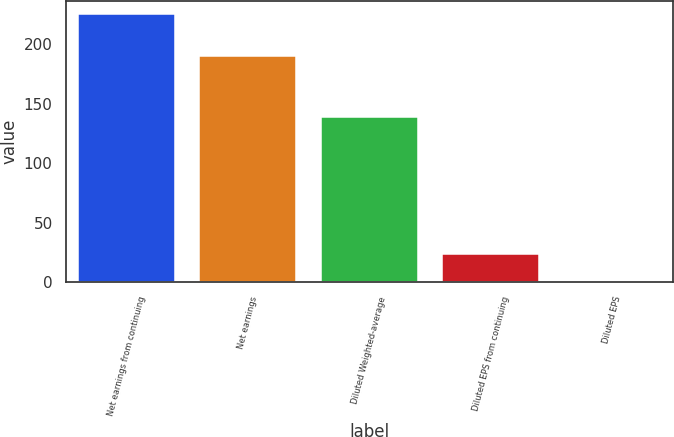Convert chart. <chart><loc_0><loc_0><loc_500><loc_500><bar_chart><fcel>Net earnings from continuing<fcel>Net earnings<fcel>Diluted Weighted-average<fcel>Diluted EPS from continuing<fcel>Diluted EPS<nl><fcel>225.1<fcel>190<fcel>139.1<fcel>23.74<fcel>1.37<nl></chart> 